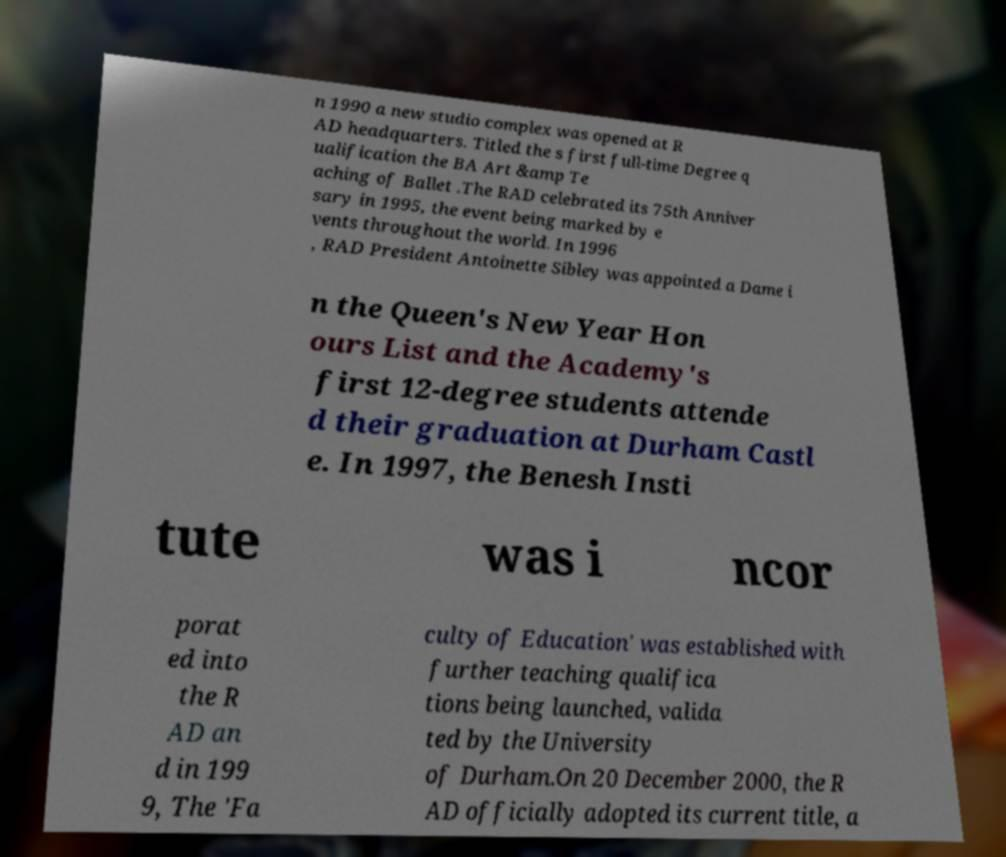Can you read and provide the text displayed in the image?This photo seems to have some interesting text. Can you extract and type it out for me? n 1990 a new studio complex was opened at R AD headquarters. Titled the s first full-time Degree q ualification the BA Art &amp Te aching of Ballet .The RAD celebrated its 75th Anniver sary in 1995, the event being marked by e vents throughout the world. In 1996 , RAD President Antoinette Sibley was appointed a Dame i n the Queen's New Year Hon ours List and the Academy's first 12-degree students attende d their graduation at Durham Castl e. In 1997, the Benesh Insti tute was i ncor porat ed into the R AD an d in 199 9, The 'Fa culty of Education' was established with further teaching qualifica tions being launched, valida ted by the University of Durham.On 20 December 2000, the R AD officially adopted its current title, a 